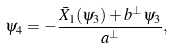Convert formula to latex. <formula><loc_0><loc_0><loc_500><loc_500>\psi _ { 4 } = - \frac { \bar { X } _ { 1 } ( \psi _ { 3 } ) + b ^ { \perp } \psi _ { 3 } } { a ^ { \perp } } ,</formula> 